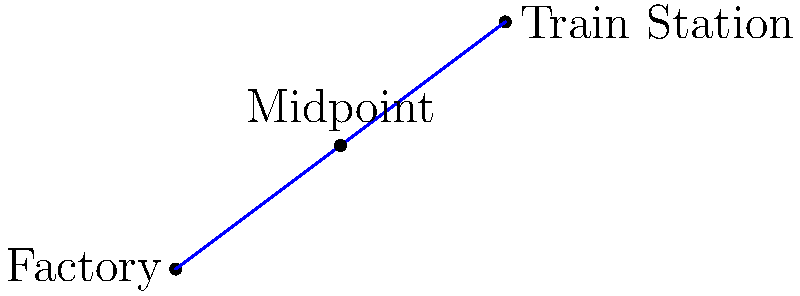On a map of a 19th-century industrial town, a cotton factory is located at coordinates (0,0) and the main train station is at (8,6). To plan for the construction of a new workers' housing development, you need to find the midpoint between these two significant locations. What are the coordinates of this midpoint? To find the midpoint between two points, we use the midpoint formula:

$$ \text{Midpoint} = (\frac{x_1 + x_2}{2}, \frac{y_1 + y_2}{2}) $$

Where $(x_1, y_1)$ are the coordinates of the first point and $(x_2, y_2)$ are the coordinates of the second point.

Given:
- Factory coordinates: $(0, 0)$
- Train station coordinates: $(8, 6)$

Step 1: Calculate the x-coordinate of the midpoint:
$$ x = \frac{0 + 8}{2} = \frac{8}{2} = 4 $$

Step 2: Calculate the y-coordinate of the midpoint:
$$ y = \frac{0 + 6}{2} = \frac{6}{2} = 3 $$

Therefore, the midpoint coordinates are $(4, 3)$.
Answer: (4, 3) 